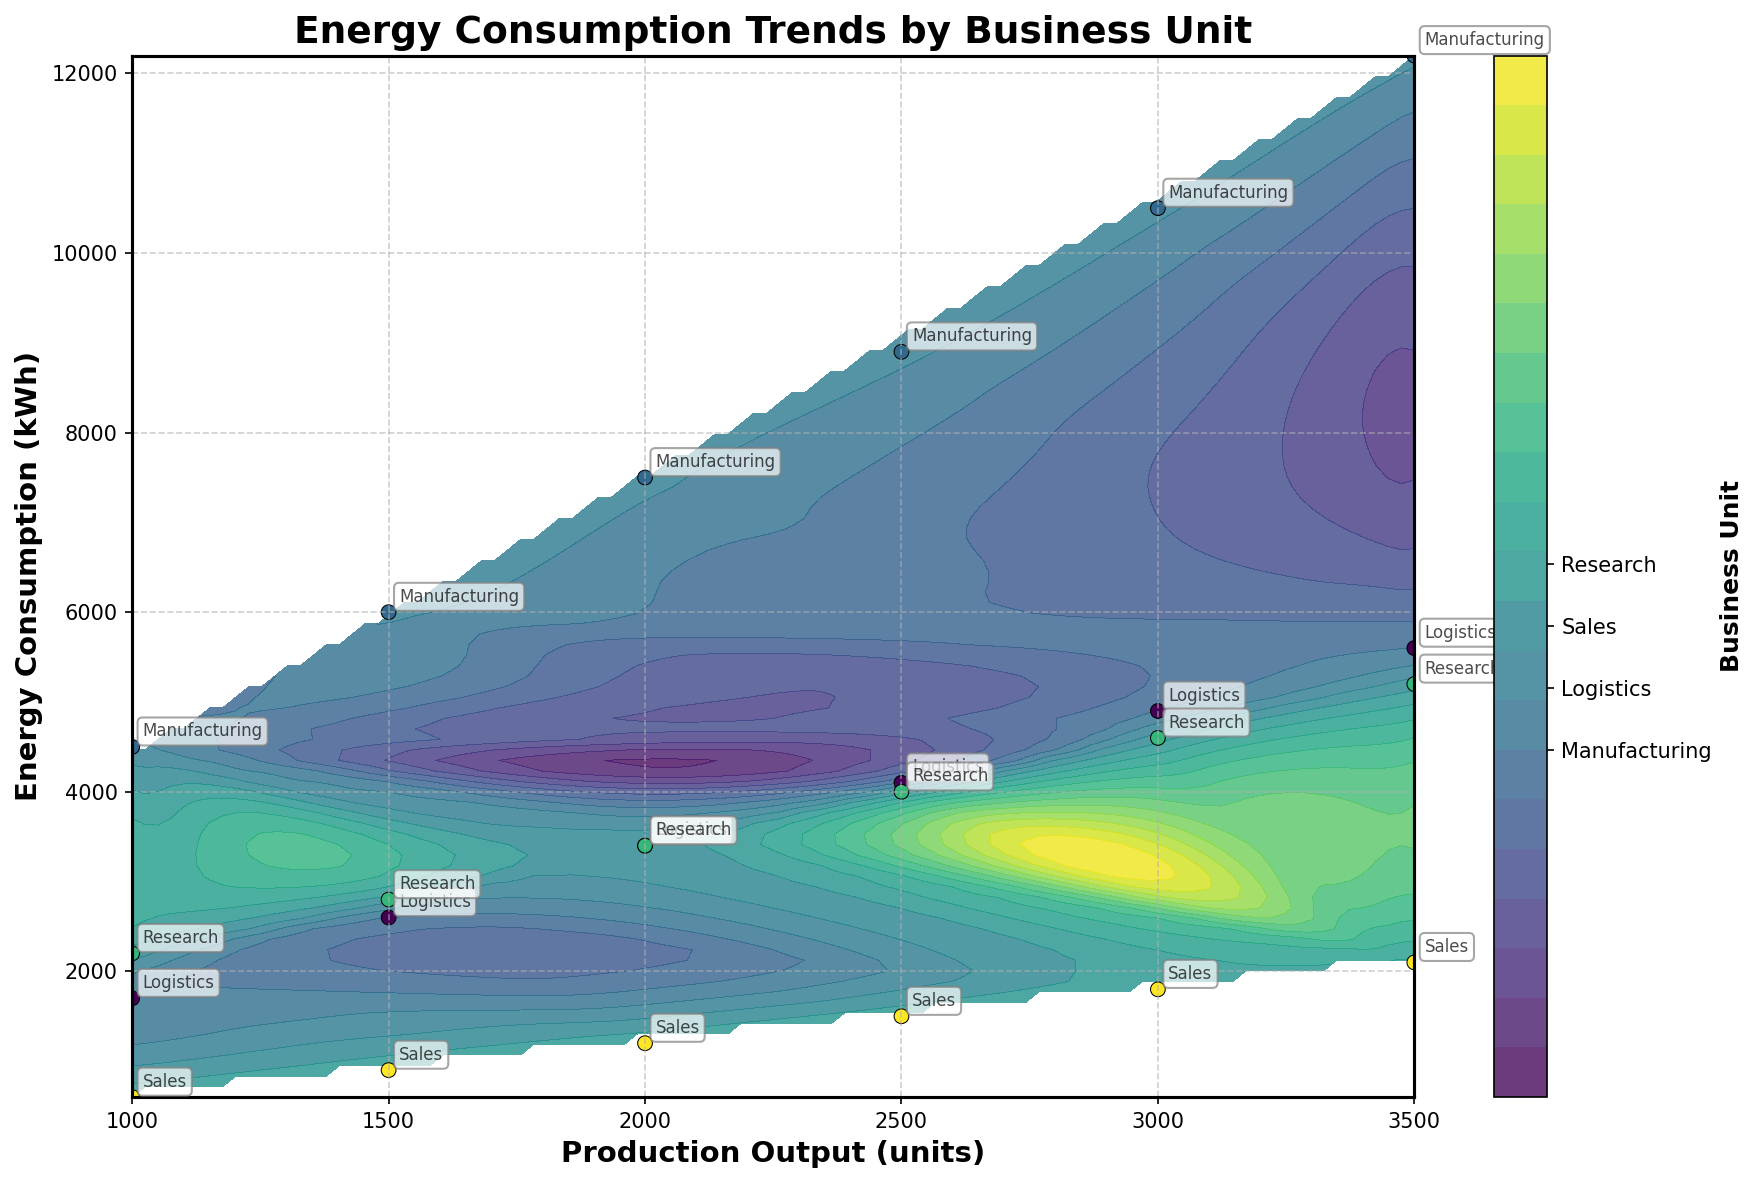What is the title of the plot? The title of the plot is displayed at the top, reading "Energy Consumption Trends by Business Unit."
Answer: Energy Consumption Trends by Business Unit What units are used for the x-axis and y-axis? The x-axis represents "Production Output (units)" and the y-axis represents "Energy Consumption (kWh)."
Answer: Production Output (units) and Energy Consumption (kWh) How many business units are represented in the plot? The colorbar on the right shows four distinct ticks, labeled as Manufacturing, Logistics, Sales, and Research, indicating four business units.
Answer: Four Which business unit has the highest energy consumption for a production output of 3500 units? At a production output of 3500 units, the highest energy consumption point belongs to the Manufacturing unit. This is evident from the scatter points and the annotations.
Answer: Manufacturing Between Manufacturing and Logistics, which unit has a steeper increase in energy consumption as production output increases? Manufacturing shows a higher energy consumption compared to Logistics for similar increases in production output, indicating a steeper increase. This can be deduced by comparing the vertical positions of data points within these two categories.
Answer: Manufacturing What colors are used to represent the business units on the plot? The viridis colormap is used. Manufacturing is shown in darker shades, Logistics in moderately dark shades, Research in lighter shades, and Sales in the lightest shades. Actual colors are specific shades from dark purple/blue to yellow.
Answer: dark purple/blue to yellow Compare the energy consumption trends of Sales and Research. Which one consumes more energy for the same production output? By examining the scatter plot and the annotations, it is clear that for the same production output levels, Research consumes significantly more energy compared to Sales.
Answer: Research What is the difference in energy consumption between Manufacturing and Sales at a production output of 2000 units? Looking at the scatter points and annotations, Manufacturing consumes 7500 kWh while Sales consumes 1200 kWh at 2000 units. The difference is 7500 - 1200 = 6300 kWh.
Answer: 6300 kWh For what production output levels do the logistics and research units have overlapping energy consumption values? By examining the scatter plot, Logistics and Research units have overlapping points around the energy consumptions of 3400 kWh and 5200 kWh respectively at production output levels of 2000 and 3500 units.
Answer: 2000 and 3500 units 